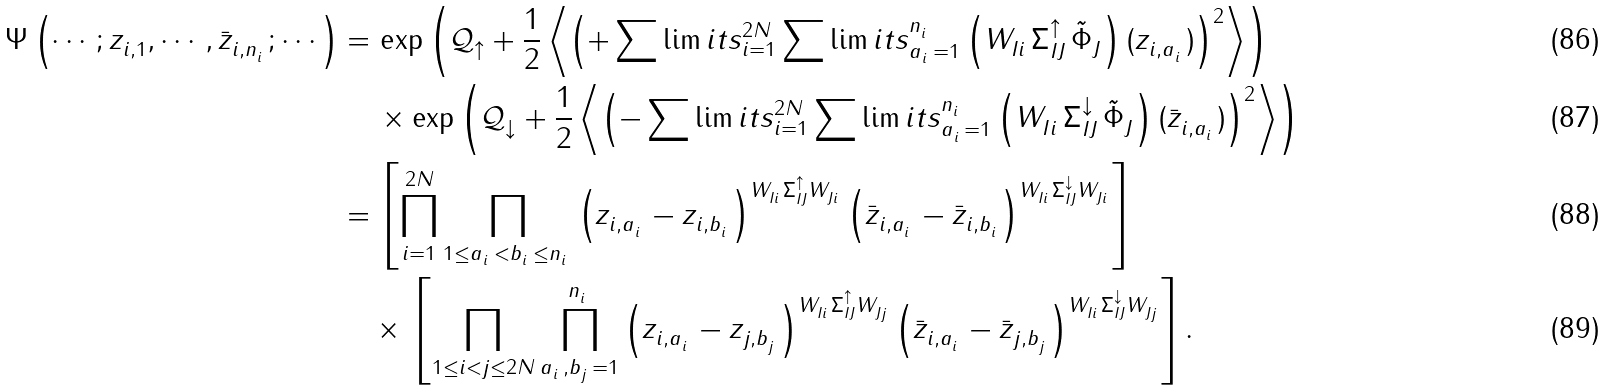<formula> <loc_0><loc_0><loc_500><loc_500>\Psi \left ( \cdots ; z ^ { \ } _ { i , 1 } , \cdots , \bar { z } ^ { \ } _ { i , n ^ { \ } _ { i } } ; \cdots \right ) = & \, \exp \left ( \mathcal { Q } ^ { \ } _ { \uparrow } + \frac { 1 } { 2 } \left \langle \left ( + \sum \lim i t s _ { i = 1 } ^ { 2 N } \sum \lim i t s _ { a ^ { \ } _ { i } = 1 } ^ { n ^ { \ } _ { i } } \left ( W ^ { \ } _ { I i } \, \Sigma ^ { \uparrow } _ { I J } \, \tilde { \Phi } ^ { \ } _ { J } \right ) ( z ^ { \ } _ { i , a ^ { \ } _ { i } } ) \right ) ^ { 2 } \right \rangle \right ) \\ & \, \times \exp \left ( \mathcal { Q } ^ { \ } _ { \downarrow } + \frac { 1 } { 2 } \left \langle \left ( - \sum \lim i t s _ { i = 1 } ^ { 2 N } \sum \lim i t s _ { a ^ { \ } _ { i } = 1 } ^ { n ^ { \ } _ { i } } \left ( W ^ { \ } _ { I i } \, \Sigma ^ { \downarrow } _ { I J } \, \tilde { \Phi } ^ { \ } _ { J } \right ) ( \bar { z } ^ { \ } _ { i , a ^ { \ } _ { i } } ) \right ) ^ { 2 } \right \rangle \right ) \\ = & \, \left [ \prod _ { i = 1 } ^ { 2 N } \prod _ { 1 \leq a ^ { \ } _ { i } < b ^ { \ } _ { i } \leq n ^ { \ } _ { i } } \left ( z ^ { \ } _ { i , a ^ { \ } _ { i } } - z ^ { \ } _ { i , b ^ { \ } _ { i } } \right ) ^ { W ^ { \ } _ { I i } \Sigma ^ { \uparrow } _ { I J } W ^ { \ } _ { J i } } \left ( \bar { z } ^ { \ } _ { i , a ^ { \ } _ { i } } - \bar { z } ^ { \ } _ { i , b ^ { \ } _ { i } } \right ) ^ { W ^ { \ } _ { I i } \Sigma ^ { \downarrow } _ { I J } W ^ { \ } _ { J i } } \right ] \\ & \times \, \left [ \prod _ { 1 \leq i < j \leq 2 N } \prod _ { a ^ { \ } _ { i } , b ^ { \ } _ { j } = 1 } ^ { n ^ { \ } _ { i } } \left ( z ^ { \ } _ { i , a ^ { \ } _ { i } } - z ^ { \ } _ { j , b ^ { \ } _ { j } } \right ) ^ { W ^ { \ } _ { I i } \Sigma ^ { \uparrow } _ { I J } W ^ { \ } _ { J j } } \left ( \bar { z } ^ { \ } _ { i , a ^ { \ } _ { i } } - \bar { z } ^ { \ } _ { j , b ^ { \ } _ { j } } \right ) ^ { W ^ { \ } _ { I i } \Sigma ^ { \downarrow } _ { I J } W ^ { \ } _ { J j } } \right ] .</formula> 